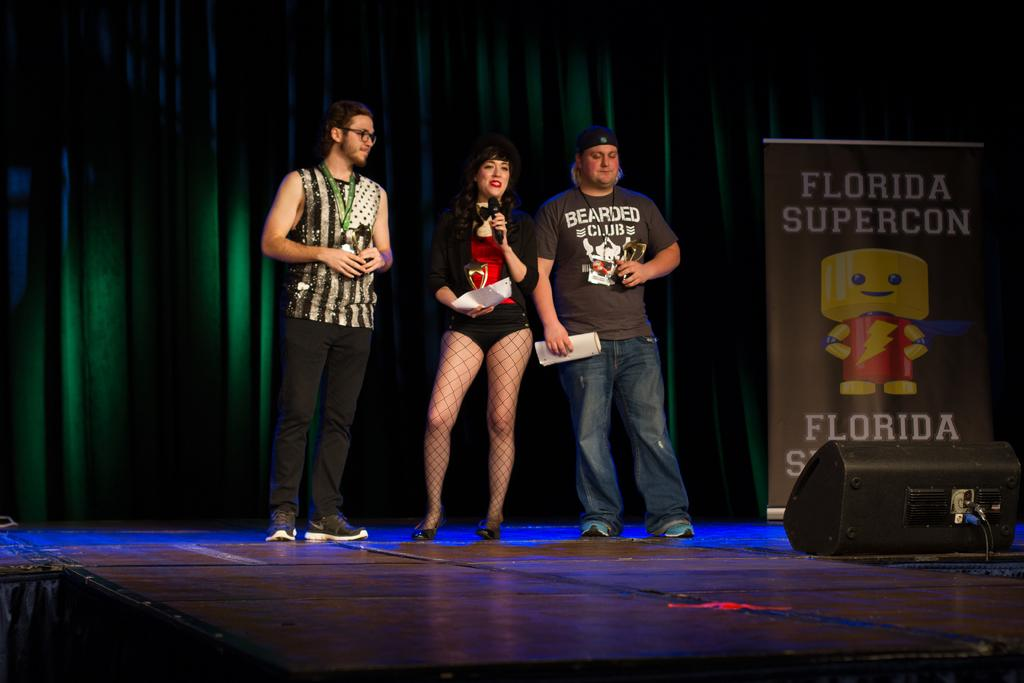<image>
Describe the image concisely. Florida Supercon is displayed from a sign on stage. 